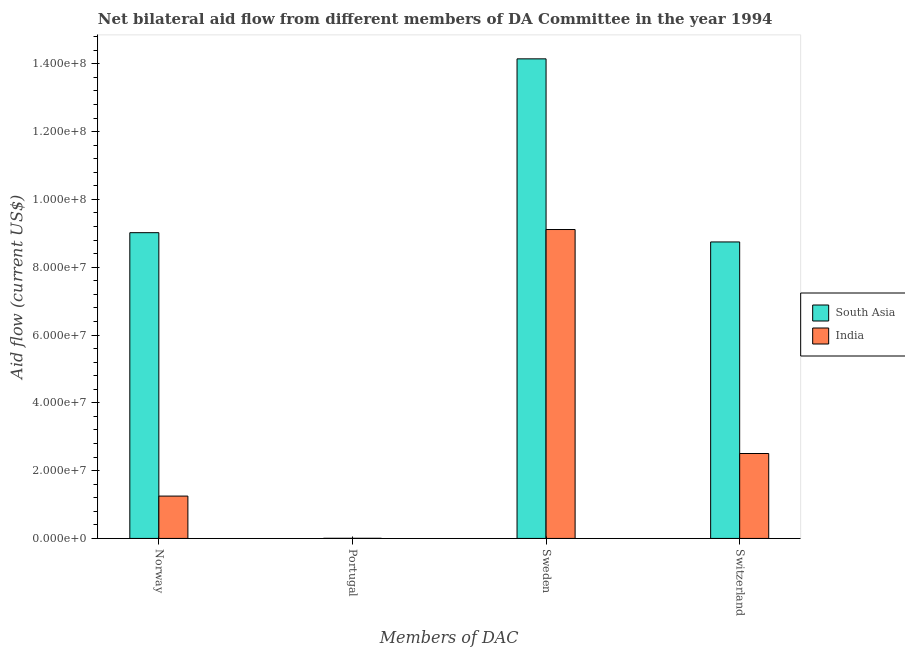Are the number of bars on each tick of the X-axis equal?
Your response must be concise. Yes. How many bars are there on the 2nd tick from the right?
Your answer should be compact. 2. What is the label of the 4th group of bars from the left?
Make the answer very short. Switzerland. What is the amount of aid given by sweden in India?
Make the answer very short. 9.11e+07. Across all countries, what is the maximum amount of aid given by switzerland?
Give a very brief answer. 8.74e+07. Across all countries, what is the minimum amount of aid given by norway?
Your answer should be compact. 1.25e+07. What is the total amount of aid given by switzerland in the graph?
Offer a terse response. 1.12e+08. What is the difference between the amount of aid given by switzerland in India and that in South Asia?
Give a very brief answer. -6.24e+07. What is the difference between the amount of aid given by norway in India and the amount of aid given by switzerland in South Asia?
Offer a terse response. -7.50e+07. What is the average amount of aid given by sweden per country?
Your answer should be compact. 1.16e+08. What is the difference between the amount of aid given by portugal and amount of aid given by switzerland in South Asia?
Offer a very short reply. -8.74e+07. In how many countries, is the amount of aid given by norway greater than 64000000 US$?
Your response must be concise. 1. What is the ratio of the amount of aid given by switzerland in South Asia to that in India?
Your answer should be very brief. 3.49. What is the difference between the highest and the second highest amount of aid given by sweden?
Your answer should be compact. 5.03e+07. In how many countries, is the amount of aid given by portugal greater than the average amount of aid given by portugal taken over all countries?
Provide a short and direct response. 0. Is it the case that in every country, the sum of the amount of aid given by sweden and amount of aid given by switzerland is greater than the sum of amount of aid given by norway and amount of aid given by portugal?
Your answer should be very brief. Yes. What does the 1st bar from the left in Portugal represents?
Your answer should be compact. South Asia. What does the 2nd bar from the right in Norway represents?
Offer a very short reply. South Asia. Is it the case that in every country, the sum of the amount of aid given by norway and amount of aid given by portugal is greater than the amount of aid given by sweden?
Ensure brevity in your answer.  No. What is the difference between two consecutive major ticks on the Y-axis?
Your answer should be very brief. 2.00e+07. Does the graph contain grids?
Offer a terse response. No. How many legend labels are there?
Make the answer very short. 2. What is the title of the graph?
Your answer should be very brief. Net bilateral aid flow from different members of DA Committee in the year 1994. What is the label or title of the X-axis?
Provide a succinct answer. Members of DAC. What is the label or title of the Y-axis?
Offer a very short reply. Aid flow (current US$). What is the Aid flow (current US$) of South Asia in Norway?
Offer a terse response. 9.02e+07. What is the Aid flow (current US$) in India in Norway?
Keep it short and to the point. 1.25e+07. What is the Aid flow (current US$) of South Asia in Sweden?
Ensure brevity in your answer.  1.41e+08. What is the Aid flow (current US$) in India in Sweden?
Provide a succinct answer. 9.11e+07. What is the Aid flow (current US$) of South Asia in Switzerland?
Give a very brief answer. 8.74e+07. What is the Aid flow (current US$) in India in Switzerland?
Give a very brief answer. 2.50e+07. Across all Members of DAC, what is the maximum Aid flow (current US$) in South Asia?
Your answer should be compact. 1.41e+08. Across all Members of DAC, what is the maximum Aid flow (current US$) of India?
Your answer should be very brief. 9.11e+07. What is the total Aid flow (current US$) in South Asia in the graph?
Provide a short and direct response. 3.19e+08. What is the total Aid flow (current US$) of India in the graph?
Give a very brief answer. 1.29e+08. What is the difference between the Aid flow (current US$) of South Asia in Norway and that in Portugal?
Your answer should be very brief. 9.01e+07. What is the difference between the Aid flow (current US$) of India in Norway and that in Portugal?
Keep it short and to the point. 1.24e+07. What is the difference between the Aid flow (current US$) of South Asia in Norway and that in Sweden?
Keep it short and to the point. -5.13e+07. What is the difference between the Aid flow (current US$) in India in Norway and that in Sweden?
Provide a succinct answer. -7.86e+07. What is the difference between the Aid flow (current US$) of South Asia in Norway and that in Switzerland?
Give a very brief answer. 2.73e+06. What is the difference between the Aid flow (current US$) in India in Norway and that in Switzerland?
Offer a terse response. -1.26e+07. What is the difference between the Aid flow (current US$) in South Asia in Portugal and that in Sweden?
Your answer should be very brief. -1.41e+08. What is the difference between the Aid flow (current US$) in India in Portugal and that in Sweden?
Make the answer very short. -9.11e+07. What is the difference between the Aid flow (current US$) of South Asia in Portugal and that in Switzerland?
Provide a short and direct response. -8.74e+07. What is the difference between the Aid flow (current US$) in India in Portugal and that in Switzerland?
Provide a succinct answer. -2.50e+07. What is the difference between the Aid flow (current US$) of South Asia in Sweden and that in Switzerland?
Provide a succinct answer. 5.40e+07. What is the difference between the Aid flow (current US$) in India in Sweden and that in Switzerland?
Ensure brevity in your answer.  6.61e+07. What is the difference between the Aid flow (current US$) in South Asia in Norway and the Aid flow (current US$) in India in Portugal?
Provide a succinct answer. 9.01e+07. What is the difference between the Aid flow (current US$) of South Asia in Norway and the Aid flow (current US$) of India in Sweden?
Offer a terse response. -9.30e+05. What is the difference between the Aid flow (current US$) of South Asia in Norway and the Aid flow (current US$) of India in Switzerland?
Provide a short and direct response. 6.51e+07. What is the difference between the Aid flow (current US$) of South Asia in Portugal and the Aid flow (current US$) of India in Sweden?
Give a very brief answer. -9.11e+07. What is the difference between the Aid flow (current US$) in South Asia in Portugal and the Aid flow (current US$) in India in Switzerland?
Your answer should be compact. -2.50e+07. What is the difference between the Aid flow (current US$) in South Asia in Sweden and the Aid flow (current US$) in India in Switzerland?
Provide a short and direct response. 1.16e+08. What is the average Aid flow (current US$) in South Asia per Members of DAC?
Your answer should be compact. 7.98e+07. What is the average Aid flow (current US$) of India per Members of DAC?
Your response must be concise. 3.22e+07. What is the difference between the Aid flow (current US$) of South Asia and Aid flow (current US$) of India in Norway?
Your answer should be compact. 7.77e+07. What is the difference between the Aid flow (current US$) of South Asia and Aid flow (current US$) of India in Sweden?
Make the answer very short. 5.03e+07. What is the difference between the Aid flow (current US$) in South Asia and Aid flow (current US$) in India in Switzerland?
Make the answer very short. 6.24e+07. What is the ratio of the Aid flow (current US$) of South Asia in Norway to that in Portugal?
Your answer should be very brief. 2254.5. What is the ratio of the Aid flow (current US$) in India in Norway to that in Portugal?
Keep it short and to the point. 312.25. What is the ratio of the Aid flow (current US$) in South Asia in Norway to that in Sweden?
Give a very brief answer. 0.64. What is the ratio of the Aid flow (current US$) in India in Norway to that in Sweden?
Your answer should be compact. 0.14. What is the ratio of the Aid flow (current US$) in South Asia in Norway to that in Switzerland?
Offer a very short reply. 1.03. What is the ratio of the Aid flow (current US$) of India in Norway to that in Switzerland?
Give a very brief answer. 0.5. What is the ratio of the Aid flow (current US$) of South Asia in Portugal to that in Sweden?
Give a very brief answer. 0. What is the ratio of the Aid flow (current US$) of South Asia in Portugal to that in Switzerland?
Your answer should be compact. 0. What is the ratio of the Aid flow (current US$) in India in Portugal to that in Switzerland?
Provide a short and direct response. 0. What is the ratio of the Aid flow (current US$) in South Asia in Sweden to that in Switzerland?
Provide a succinct answer. 1.62. What is the ratio of the Aid flow (current US$) of India in Sweden to that in Switzerland?
Your answer should be compact. 3.64. What is the difference between the highest and the second highest Aid flow (current US$) in South Asia?
Give a very brief answer. 5.13e+07. What is the difference between the highest and the second highest Aid flow (current US$) of India?
Ensure brevity in your answer.  6.61e+07. What is the difference between the highest and the lowest Aid flow (current US$) in South Asia?
Provide a short and direct response. 1.41e+08. What is the difference between the highest and the lowest Aid flow (current US$) of India?
Offer a terse response. 9.11e+07. 